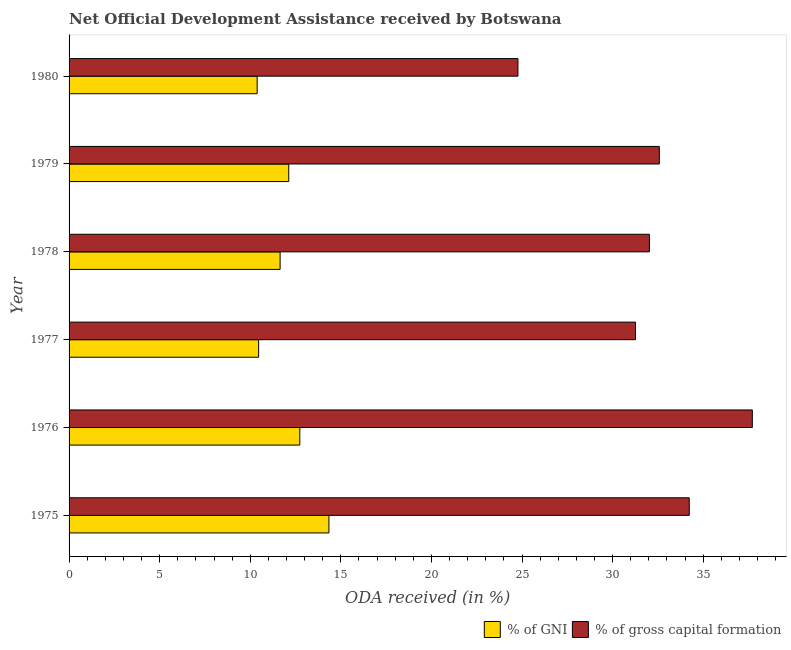How many different coloured bars are there?
Offer a terse response. 2. How many groups of bars are there?
Your answer should be compact. 6. What is the oda received as percentage of gni in 1977?
Ensure brevity in your answer.  10.46. Across all years, what is the maximum oda received as percentage of gni?
Your response must be concise. 14.34. Across all years, what is the minimum oda received as percentage of gni?
Your answer should be very brief. 10.38. In which year was the oda received as percentage of gni maximum?
Your answer should be very brief. 1975. What is the total oda received as percentage of gni in the graph?
Provide a succinct answer. 71.69. What is the difference between the oda received as percentage of gross capital formation in 1976 and that in 1977?
Your answer should be very brief. 6.45. What is the difference between the oda received as percentage of gross capital formation in 1975 and the oda received as percentage of gni in 1977?
Offer a terse response. 23.77. What is the average oda received as percentage of gni per year?
Provide a succinct answer. 11.95. In the year 1977, what is the difference between the oda received as percentage of gni and oda received as percentage of gross capital formation?
Offer a terse response. -20.8. What is the difference between the highest and the second highest oda received as percentage of gross capital formation?
Keep it short and to the point. 3.48. What is the difference between the highest and the lowest oda received as percentage of gni?
Give a very brief answer. 3.96. Is the sum of the oda received as percentage of gni in 1975 and 1976 greater than the maximum oda received as percentage of gross capital formation across all years?
Give a very brief answer. No. What does the 2nd bar from the top in 1980 represents?
Provide a short and direct response. % of GNI. What does the 1st bar from the bottom in 1977 represents?
Make the answer very short. % of GNI. Are all the bars in the graph horizontal?
Keep it short and to the point. Yes. How many years are there in the graph?
Provide a succinct answer. 6. Does the graph contain any zero values?
Provide a short and direct response. No. Where does the legend appear in the graph?
Your answer should be compact. Bottom right. How are the legend labels stacked?
Give a very brief answer. Horizontal. What is the title of the graph?
Give a very brief answer. Net Official Development Assistance received by Botswana. Does "Lowest 10% of population" appear as one of the legend labels in the graph?
Offer a very short reply. No. What is the label or title of the X-axis?
Your answer should be very brief. ODA received (in %). What is the ODA received (in %) of % of GNI in 1975?
Keep it short and to the point. 14.34. What is the ODA received (in %) in % of gross capital formation in 1975?
Provide a short and direct response. 34.23. What is the ODA received (in %) of % of GNI in 1976?
Provide a succinct answer. 12.74. What is the ODA received (in %) of % of gross capital formation in 1976?
Offer a very short reply. 37.71. What is the ODA received (in %) in % of GNI in 1977?
Provide a short and direct response. 10.46. What is the ODA received (in %) of % of gross capital formation in 1977?
Provide a short and direct response. 31.26. What is the ODA received (in %) of % of GNI in 1978?
Provide a succinct answer. 11.65. What is the ODA received (in %) in % of gross capital formation in 1978?
Your response must be concise. 32.03. What is the ODA received (in %) of % of GNI in 1979?
Make the answer very short. 12.13. What is the ODA received (in %) in % of gross capital formation in 1979?
Give a very brief answer. 32.58. What is the ODA received (in %) in % of GNI in 1980?
Your response must be concise. 10.38. What is the ODA received (in %) in % of gross capital formation in 1980?
Offer a very short reply. 24.77. Across all years, what is the maximum ODA received (in %) in % of GNI?
Your response must be concise. 14.34. Across all years, what is the maximum ODA received (in %) in % of gross capital formation?
Your answer should be compact. 37.71. Across all years, what is the minimum ODA received (in %) in % of GNI?
Keep it short and to the point. 10.38. Across all years, what is the minimum ODA received (in %) of % of gross capital formation?
Your answer should be compact. 24.77. What is the total ODA received (in %) in % of GNI in the graph?
Ensure brevity in your answer.  71.69. What is the total ODA received (in %) in % of gross capital formation in the graph?
Give a very brief answer. 192.59. What is the difference between the ODA received (in %) of % of GNI in 1975 and that in 1976?
Provide a succinct answer. 1.61. What is the difference between the ODA received (in %) in % of gross capital formation in 1975 and that in 1976?
Your response must be concise. -3.48. What is the difference between the ODA received (in %) in % of GNI in 1975 and that in 1977?
Provide a short and direct response. 3.88. What is the difference between the ODA received (in %) of % of gross capital formation in 1975 and that in 1977?
Your response must be concise. 2.97. What is the difference between the ODA received (in %) of % of GNI in 1975 and that in 1978?
Your response must be concise. 2.69. What is the difference between the ODA received (in %) of % of gross capital formation in 1975 and that in 1978?
Provide a succinct answer. 2.2. What is the difference between the ODA received (in %) of % of GNI in 1975 and that in 1979?
Offer a terse response. 2.22. What is the difference between the ODA received (in %) of % of gross capital formation in 1975 and that in 1979?
Provide a succinct answer. 1.65. What is the difference between the ODA received (in %) of % of GNI in 1975 and that in 1980?
Offer a very short reply. 3.96. What is the difference between the ODA received (in %) of % of gross capital formation in 1975 and that in 1980?
Ensure brevity in your answer.  9.46. What is the difference between the ODA received (in %) in % of GNI in 1976 and that in 1977?
Offer a terse response. 2.27. What is the difference between the ODA received (in %) of % of gross capital formation in 1976 and that in 1977?
Offer a terse response. 6.45. What is the difference between the ODA received (in %) in % of GNI in 1976 and that in 1978?
Provide a succinct answer. 1.09. What is the difference between the ODA received (in %) in % of gross capital formation in 1976 and that in 1978?
Provide a succinct answer. 5.68. What is the difference between the ODA received (in %) in % of GNI in 1976 and that in 1979?
Ensure brevity in your answer.  0.61. What is the difference between the ODA received (in %) in % of gross capital formation in 1976 and that in 1979?
Make the answer very short. 5.13. What is the difference between the ODA received (in %) of % of GNI in 1976 and that in 1980?
Offer a terse response. 2.35. What is the difference between the ODA received (in %) in % of gross capital formation in 1976 and that in 1980?
Make the answer very short. 12.94. What is the difference between the ODA received (in %) in % of GNI in 1977 and that in 1978?
Ensure brevity in your answer.  -1.19. What is the difference between the ODA received (in %) in % of gross capital formation in 1977 and that in 1978?
Your answer should be very brief. -0.77. What is the difference between the ODA received (in %) of % of GNI in 1977 and that in 1979?
Your answer should be very brief. -1.66. What is the difference between the ODA received (in %) in % of gross capital formation in 1977 and that in 1979?
Make the answer very short. -1.31. What is the difference between the ODA received (in %) of % of GNI in 1977 and that in 1980?
Offer a terse response. 0.08. What is the difference between the ODA received (in %) of % of gross capital formation in 1977 and that in 1980?
Keep it short and to the point. 6.49. What is the difference between the ODA received (in %) of % of GNI in 1978 and that in 1979?
Your answer should be compact. -0.48. What is the difference between the ODA received (in %) in % of gross capital formation in 1978 and that in 1979?
Make the answer very short. -0.55. What is the difference between the ODA received (in %) in % of GNI in 1978 and that in 1980?
Offer a very short reply. 1.27. What is the difference between the ODA received (in %) in % of gross capital formation in 1978 and that in 1980?
Offer a terse response. 7.26. What is the difference between the ODA received (in %) of % of GNI in 1979 and that in 1980?
Give a very brief answer. 1.74. What is the difference between the ODA received (in %) in % of gross capital formation in 1979 and that in 1980?
Offer a very short reply. 7.8. What is the difference between the ODA received (in %) of % of GNI in 1975 and the ODA received (in %) of % of gross capital formation in 1976?
Provide a succinct answer. -23.37. What is the difference between the ODA received (in %) of % of GNI in 1975 and the ODA received (in %) of % of gross capital formation in 1977?
Keep it short and to the point. -16.92. What is the difference between the ODA received (in %) in % of GNI in 1975 and the ODA received (in %) in % of gross capital formation in 1978?
Your answer should be compact. -17.69. What is the difference between the ODA received (in %) in % of GNI in 1975 and the ODA received (in %) in % of gross capital formation in 1979?
Provide a succinct answer. -18.23. What is the difference between the ODA received (in %) in % of GNI in 1975 and the ODA received (in %) in % of gross capital formation in 1980?
Offer a terse response. -10.43. What is the difference between the ODA received (in %) of % of GNI in 1976 and the ODA received (in %) of % of gross capital formation in 1977?
Provide a short and direct response. -18.53. What is the difference between the ODA received (in %) of % of GNI in 1976 and the ODA received (in %) of % of gross capital formation in 1978?
Make the answer very short. -19.3. What is the difference between the ODA received (in %) of % of GNI in 1976 and the ODA received (in %) of % of gross capital formation in 1979?
Make the answer very short. -19.84. What is the difference between the ODA received (in %) in % of GNI in 1976 and the ODA received (in %) in % of gross capital formation in 1980?
Provide a short and direct response. -12.04. What is the difference between the ODA received (in %) in % of GNI in 1977 and the ODA received (in %) in % of gross capital formation in 1978?
Offer a very short reply. -21.57. What is the difference between the ODA received (in %) of % of GNI in 1977 and the ODA received (in %) of % of gross capital formation in 1979?
Ensure brevity in your answer.  -22.12. What is the difference between the ODA received (in %) of % of GNI in 1977 and the ODA received (in %) of % of gross capital formation in 1980?
Offer a terse response. -14.31. What is the difference between the ODA received (in %) of % of GNI in 1978 and the ODA received (in %) of % of gross capital formation in 1979?
Make the answer very short. -20.93. What is the difference between the ODA received (in %) in % of GNI in 1978 and the ODA received (in %) in % of gross capital formation in 1980?
Your response must be concise. -13.13. What is the difference between the ODA received (in %) of % of GNI in 1979 and the ODA received (in %) of % of gross capital formation in 1980?
Provide a short and direct response. -12.65. What is the average ODA received (in %) of % of GNI per year?
Your answer should be very brief. 11.95. What is the average ODA received (in %) in % of gross capital formation per year?
Offer a terse response. 32.1. In the year 1975, what is the difference between the ODA received (in %) in % of GNI and ODA received (in %) in % of gross capital formation?
Your response must be concise. -19.89. In the year 1976, what is the difference between the ODA received (in %) in % of GNI and ODA received (in %) in % of gross capital formation?
Make the answer very short. -24.98. In the year 1977, what is the difference between the ODA received (in %) in % of GNI and ODA received (in %) in % of gross capital formation?
Your answer should be compact. -20.8. In the year 1978, what is the difference between the ODA received (in %) of % of GNI and ODA received (in %) of % of gross capital formation?
Your answer should be very brief. -20.38. In the year 1979, what is the difference between the ODA received (in %) in % of GNI and ODA received (in %) in % of gross capital formation?
Your answer should be very brief. -20.45. In the year 1980, what is the difference between the ODA received (in %) of % of GNI and ODA received (in %) of % of gross capital formation?
Make the answer very short. -14.39. What is the ratio of the ODA received (in %) in % of GNI in 1975 to that in 1976?
Provide a short and direct response. 1.13. What is the ratio of the ODA received (in %) of % of gross capital formation in 1975 to that in 1976?
Your response must be concise. 0.91. What is the ratio of the ODA received (in %) of % of GNI in 1975 to that in 1977?
Offer a very short reply. 1.37. What is the ratio of the ODA received (in %) in % of gross capital formation in 1975 to that in 1977?
Offer a terse response. 1.09. What is the ratio of the ODA received (in %) in % of GNI in 1975 to that in 1978?
Offer a terse response. 1.23. What is the ratio of the ODA received (in %) in % of gross capital formation in 1975 to that in 1978?
Provide a succinct answer. 1.07. What is the ratio of the ODA received (in %) in % of GNI in 1975 to that in 1979?
Ensure brevity in your answer.  1.18. What is the ratio of the ODA received (in %) of % of gross capital formation in 1975 to that in 1979?
Give a very brief answer. 1.05. What is the ratio of the ODA received (in %) in % of GNI in 1975 to that in 1980?
Make the answer very short. 1.38. What is the ratio of the ODA received (in %) in % of gross capital formation in 1975 to that in 1980?
Provide a short and direct response. 1.38. What is the ratio of the ODA received (in %) of % of GNI in 1976 to that in 1977?
Provide a succinct answer. 1.22. What is the ratio of the ODA received (in %) of % of gross capital formation in 1976 to that in 1977?
Make the answer very short. 1.21. What is the ratio of the ODA received (in %) of % of GNI in 1976 to that in 1978?
Make the answer very short. 1.09. What is the ratio of the ODA received (in %) of % of gross capital formation in 1976 to that in 1978?
Make the answer very short. 1.18. What is the ratio of the ODA received (in %) in % of GNI in 1976 to that in 1979?
Your response must be concise. 1.05. What is the ratio of the ODA received (in %) of % of gross capital formation in 1976 to that in 1979?
Make the answer very short. 1.16. What is the ratio of the ODA received (in %) in % of GNI in 1976 to that in 1980?
Your answer should be very brief. 1.23. What is the ratio of the ODA received (in %) in % of gross capital formation in 1976 to that in 1980?
Keep it short and to the point. 1.52. What is the ratio of the ODA received (in %) in % of GNI in 1977 to that in 1978?
Your response must be concise. 0.9. What is the ratio of the ODA received (in %) in % of GNI in 1977 to that in 1979?
Ensure brevity in your answer.  0.86. What is the ratio of the ODA received (in %) in % of gross capital formation in 1977 to that in 1979?
Give a very brief answer. 0.96. What is the ratio of the ODA received (in %) in % of GNI in 1977 to that in 1980?
Provide a succinct answer. 1.01. What is the ratio of the ODA received (in %) of % of gross capital formation in 1977 to that in 1980?
Your answer should be very brief. 1.26. What is the ratio of the ODA received (in %) of % of GNI in 1978 to that in 1979?
Your response must be concise. 0.96. What is the ratio of the ODA received (in %) in % of gross capital formation in 1978 to that in 1979?
Your answer should be very brief. 0.98. What is the ratio of the ODA received (in %) in % of GNI in 1978 to that in 1980?
Your response must be concise. 1.12. What is the ratio of the ODA received (in %) in % of gross capital formation in 1978 to that in 1980?
Provide a short and direct response. 1.29. What is the ratio of the ODA received (in %) in % of GNI in 1979 to that in 1980?
Provide a short and direct response. 1.17. What is the ratio of the ODA received (in %) in % of gross capital formation in 1979 to that in 1980?
Your answer should be very brief. 1.31. What is the difference between the highest and the second highest ODA received (in %) of % of GNI?
Your answer should be compact. 1.61. What is the difference between the highest and the second highest ODA received (in %) in % of gross capital formation?
Offer a very short reply. 3.48. What is the difference between the highest and the lowest ODA received (in %) of % of GNI?
Your answer should be very brief. 3.96. What is the difference between the highest and the lowest ODA received (in %) in % of gross capital formation?
Your answer should be compact. 12.94. 